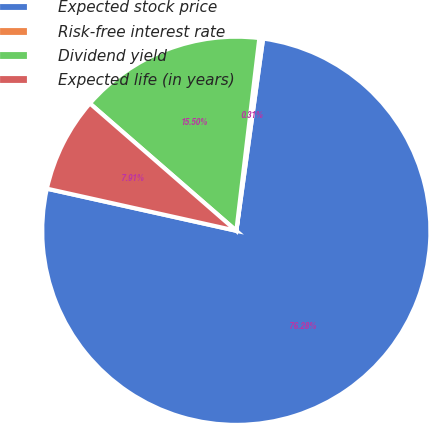Convert chart. <chart><loc_0><loc_0><loc_500><loc_500><pie_chart><fcel>Expected stock price<fcel>Risk-free interest rate<fcel>Dividend yield<fcel>Expected life (in years)<nl><fcel>76.28%<fcel>0.31%<fcel>15.5%<fcel>7.91%<nl></chart> 